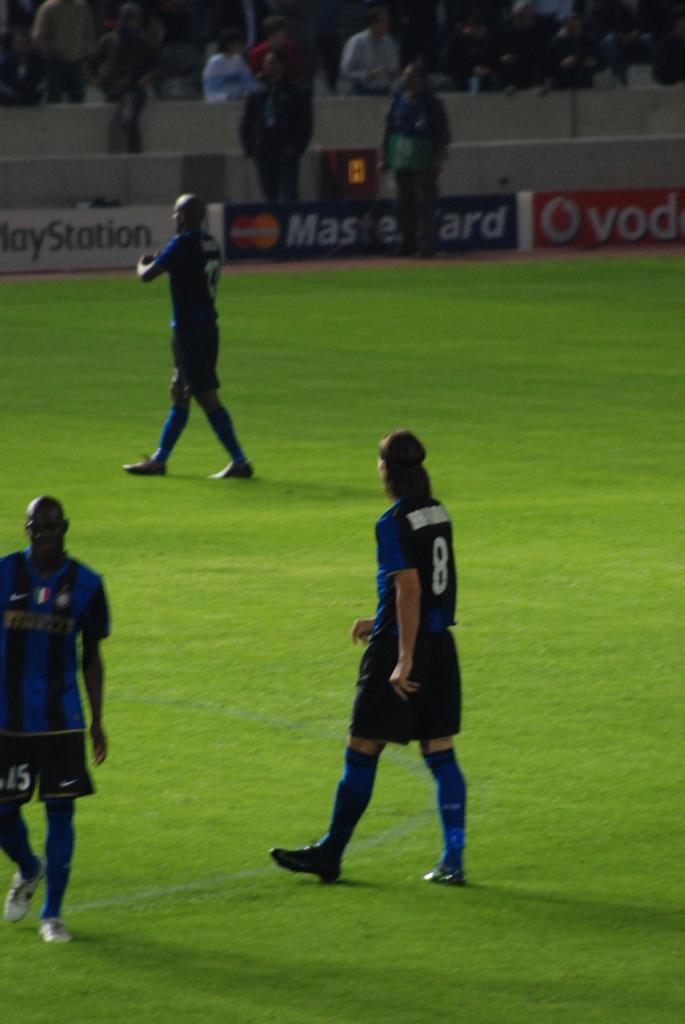What number is on the closest member's jersey?
Make the answer very short. 8. 